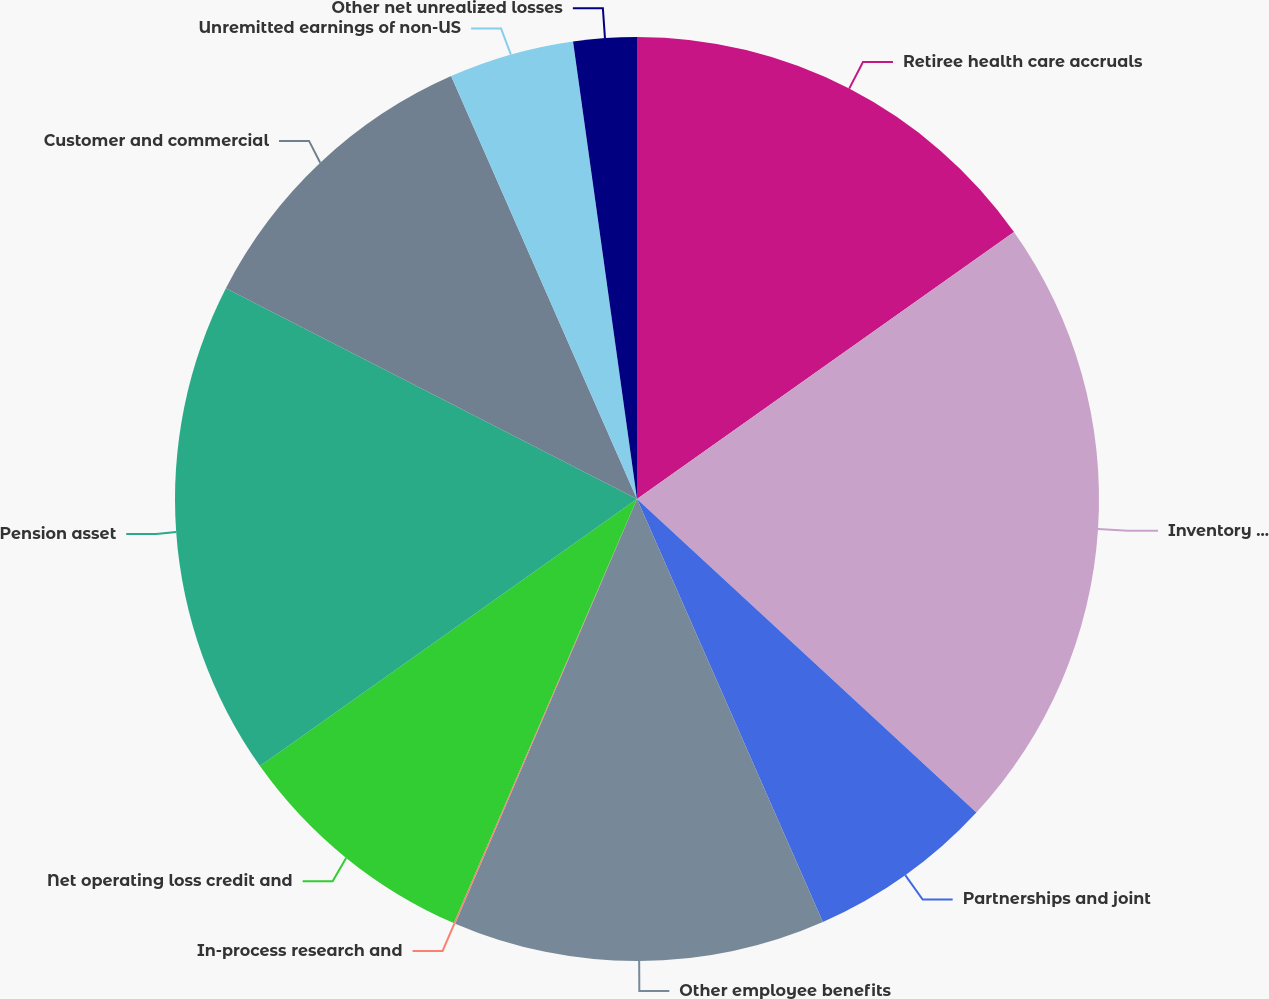<chart> <loc_0><loc_0><loc_500><loc_500><pie_chart><fcel>Retiree health care accruals<fcel>Inventory and long-term<fcel>Partnerships and joint<fcel>Other employee benefits<fcel>In-process research and<fcel>Net operating loss credit and<fcel>Pension asset<fcel>Customer and commercial<fcel>Unremitted earnings of non-US<fcel>Other net unrealized losses<nl><fcel>15.19%<fcel>21.68%<fcel>6.54%<fcel>13.03%<fcel>0.05%<fcel>8.7%<fcel>17.35%<fcel>10.87%<fcel>4.38%<fcel>2.21%<nl></chart> 